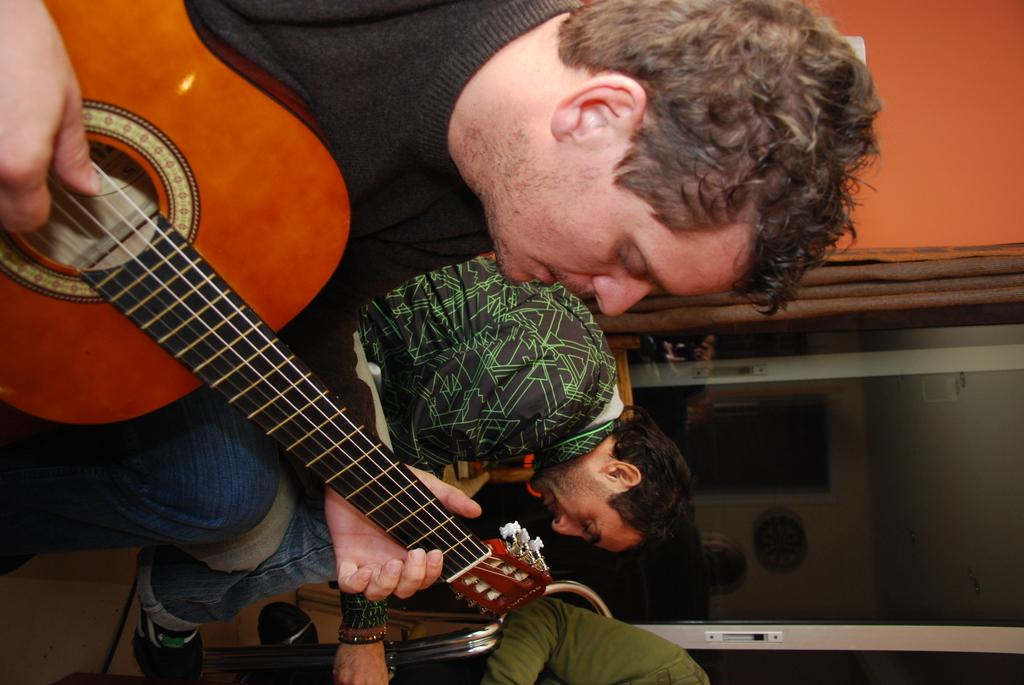How many people are in the image? There are three persons in the image. What are the people in the image doing? All three persons are sitting. Can you describe the background of the image? There is a door visible in the background. What is the person wearing a black shirt doing? The person wearing a black shirt is playing a guitar. What type of appliance can be seen in the image? There is no appliance present in the image. What attraction is visible in the background of the image? There is no attraction visible in the image; only a door is present in the background. 